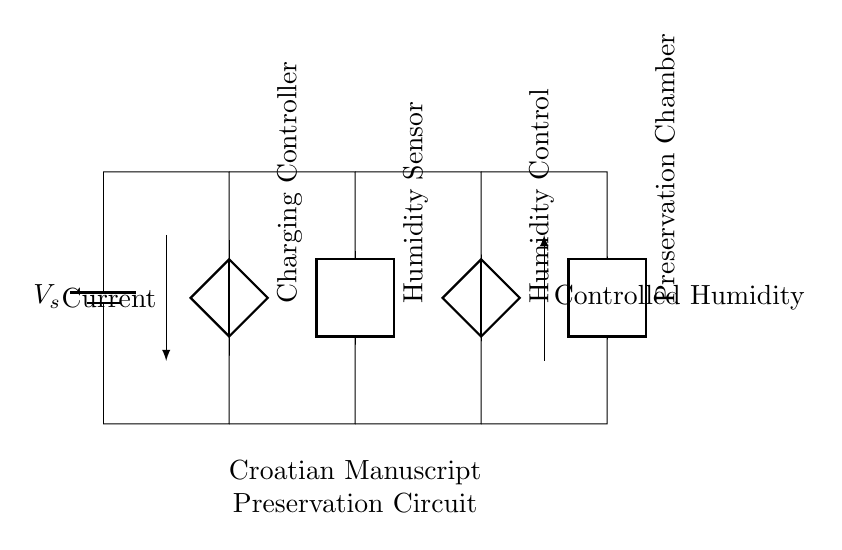What is the power source in the circuit? The power source is identified as a battery labeled with V_s, which supplies the necessary voltage for the circuit operation.
Answer: battery V_s What is the function of the humidity sensor? The humidity sensor is directly connected to the circuit and is responsible for detecting the moisture levels in the preservation chamber to maintain controlled humidity.
Answer: Humidity detection What is the purpose of the charging controller? The charging controller regulates the power received from the battery, ensuring it is suitable for the connected components, particularly for the humidity control unit.
Answer: Power regulation How many components are used in the circuit? The circuit diagram includes four main components: a battery, a charging controller, a humidity sensor, and a humidity control unit, plus a preservation chamber.
Answer: Four components What kind of current flows through this circuit? The circuit facilitates a direct current provided by the battery, which powers all connected units for manuscript preservation.
Answer: Direct current Which component is responsible for maintaining the humidity levels? The humidity control unit is tasked with adjusting and maintaining the humidity within the preservation chamber, based on readings from the humidity sensor.
Answer: Humidity control unit 